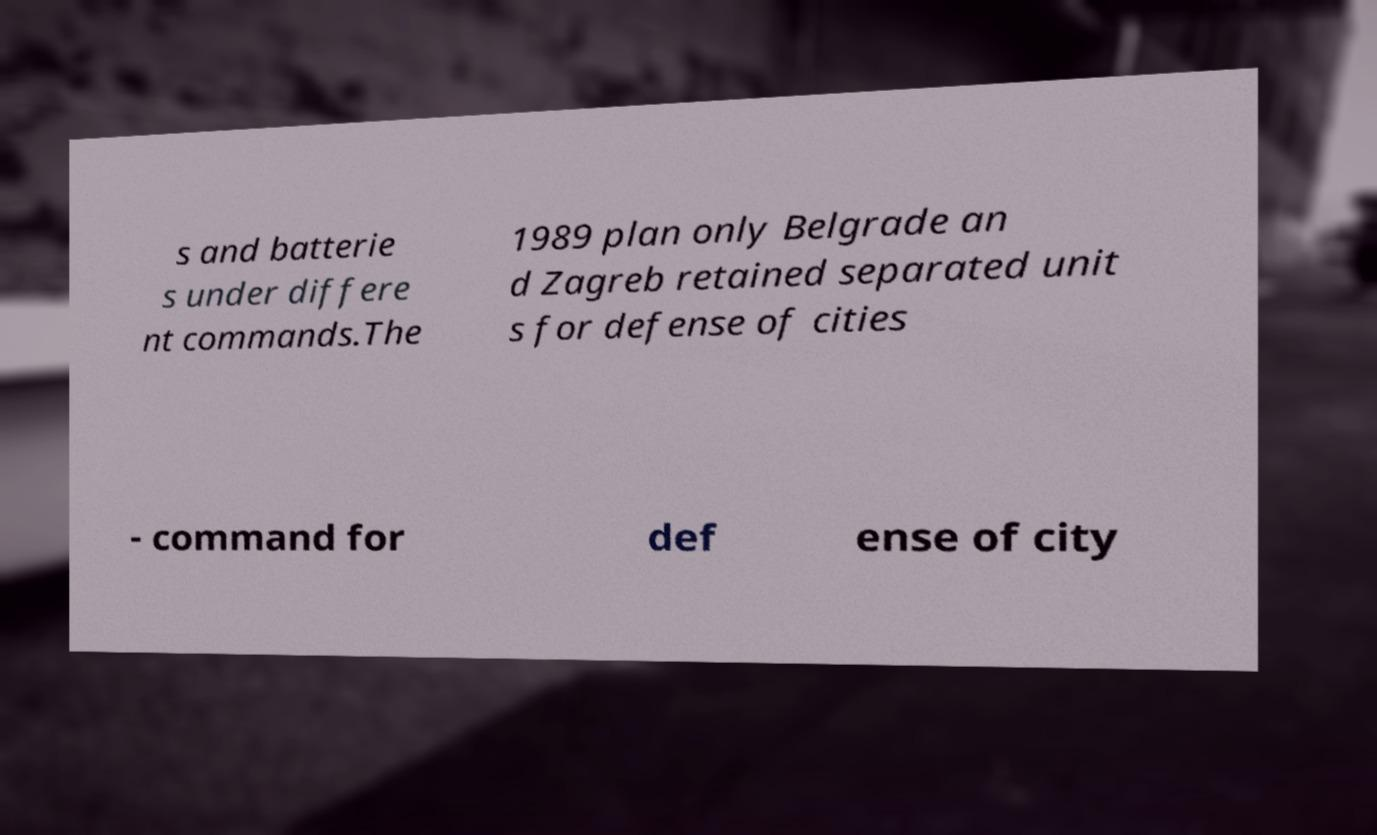What messages or text are displayed in this image? I need them in a readable, typed format. s and batterie s under differe nt commands.The 1989 plan only Belgrade an d Zagreb retained separated unit s for defense of cities - command for def ense of city 